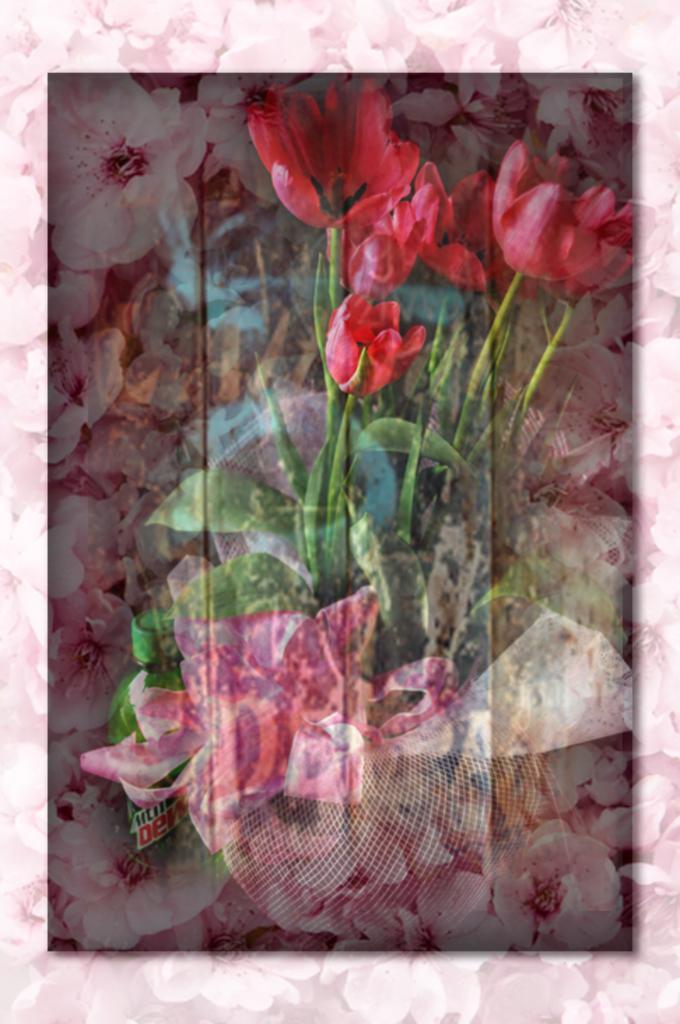Can you describe this image briefly? In this image there is a greeting card with flowers and leaves on it. 